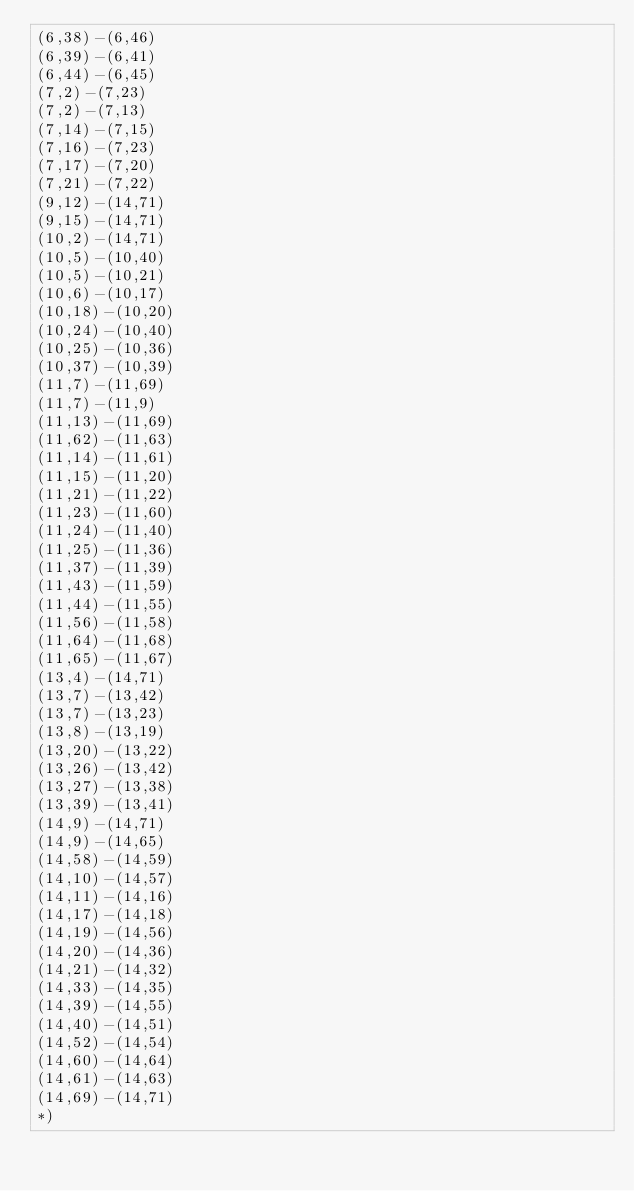<code> <loc_0><loc_0><loc_500><loc_500><_OCaml_>(6,38)-(6,46)
(6,39)-(6,41)
(6,44)-(6,45)
(7,2)-(7,23)
(7,2)-(7,13)
(7,14)-(7,15)
(7,16)-(7,23)
(7,17)-(7,20)
(7,21)-(7,22)
(9,12)-(14,71)
(9,15)-(14,71)
(10,2)-(14,71)
(10,5)-(10,40)
(10,5)-(10,21)
(10,6)-(10,17)
(10,18)-(10,20)
(10,24)-(10,40)
(10,25)-(10,36)
(10,37)-(10,39)
(11,7)-(11,69)
(11,7)-(11,9)
(11,13)-(11,69)
(11,62)-(11,63)
(11,14)-(11,61)
(11,15)-(11,20)
(11,21)-(11,22)
(11,23)-(11,60)
(11,24)-(11,40)
(11,25)-(11,36)
(11,37)-(11,39)
(11,43)-(11,59)
(11,44)-(11,55)
(11,56)-(11,58)
(11,64)-(11,68)
(11,65)-(11,67)
(13,4)-(14,71)
(13,7)-(13,42)
(13,7)-(13,23)
(13,8)-(13,19)
(13,20)-(13,22)
(13,26)-(13,42)
(13,27)-(13,38)
(13,39)-(13,41)
(14,9)-(14,71)
(14,9)-(14,65)
(14,58)-(14,59)
(14,10)-(14,57)
(14,11)-(14,16)
(14,17)-(14,18)
(14,19)-(14,56)
(14,20)-(14,36)
(14,21)-(14,32)
(14,33)-(14,35)
(14,39)-(14,55)
(14,40)-(14,51)
(14,52)-(14,54)
(14,60)-(14,64)
(14,61)-(14,63)
(14,69)-(14,71)
*)
</code> 